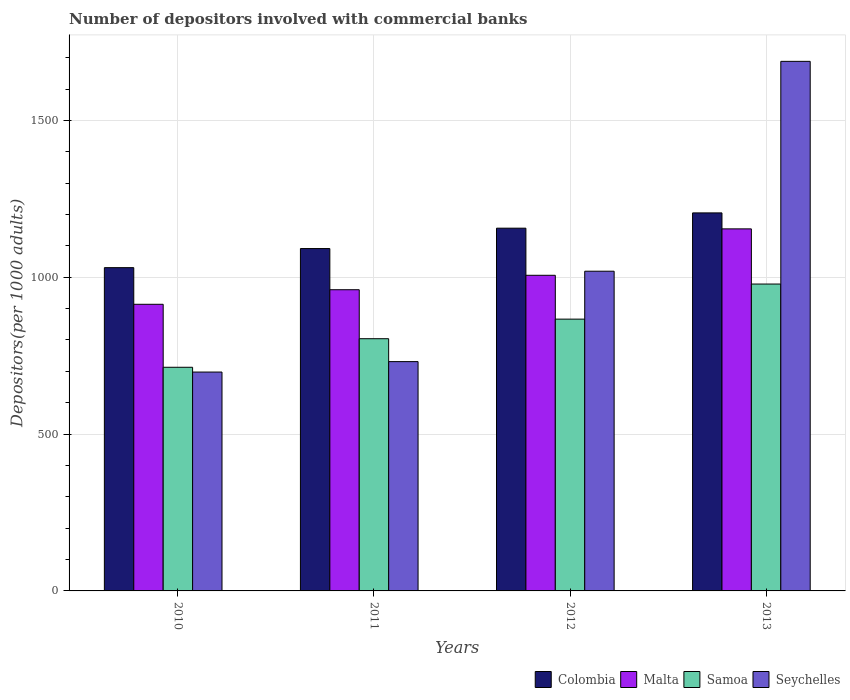How many groups of bars are there?
Give a very brief answer. 4. Are the number of bars per tick equal to the number of legend labels?
Offer a very short reply. Yes. Are the number of bars on each tick of the X-axis equal?
Give a very brief answer. Yes. What is the label of the 3rd group of bars from the left?
Your response must be concise. 2012. What is the number of depositors involved with commercial banks in Samoa in 2012?
Provide a succinct answer. 866.45. Across all years, what is the maximum number of depositors involved with commercial banks in Seychelles?
Make the answer very short. 1688.27. Across all years, what is the minimum number of depositors involved with commercial banks in Samoa?
Your answer should be compact. 713.02. In which year was the number of depositors involved with commercial banks in Seychelles maximum?
Provide a short and direct response. 2013. In which year was the number of depositors involved with commercial banks in Colombia minimum?
Your answer should be compact. 2010. What is the total number of depositors involved with commercial banks in Samoa in the graph?
Offer a terse response. 3361.86. What is the difference between the number of depositors involved with commercial banks in Colombia in 2010 and that in 2011?
Provide a succinct answer. -60.9. What is the difference between the number of depositors involved with commercial banks in Seychelles in 2010 and the number of depositors involved with commercial banks in Malta in 2012?
Give a very brief answer. -308.49. What is the average number of depositors involved with commercial banks in Samoa per year?
Offer a terse response. 840.47. In the year 2013, what is the difference between the number of depositors involved with commercial banks in Samoa and number of depositors involved with commercial banks in Colombia?
Give a very brief answer. -226.78. In how many years, is the number of depositors involved with commercial banks in Malta greater than 200?
Give a very brief answer. 4. What is the ratio of the number of depositors involved with commercial banks in Colombia in 2011 to that in 2013?
Give a very brief answer. 0.91. Is the number of depositors involved with commercial banks in Samoa in 2011 less than that in 2012?
Provide a succinct answer. Yes. What is the difference between the highest and the second highest number of depositors involved with commercial banks in Seychelles?
Your response must be concise. 669.03. What is the difference between the highest and the lowest number of depositors involved with commercial banks in Colombia?
Provide a succinct answer. 174.54. Is the sum of the number of depositors involved with commercial banks in Samoa in 2011 and 2012 greater than the maximum number of depositors involved with commercial banks in Malta across all years?
Offer a terse response. Yes. Is it the case that in every year, the sum of the number of depositors involved with commercial banks in Seychelles and number of depositors involved with commercial banks in Malta is greater than the sum of number of depositors involved with commercial banks in Samoa and number of depositors involved with commercial banks in Colombia?
Offer a very short reply. No. Is it the case that in every year, the sum of the number of depositors involved with commercial banks in Samoa and number of depositors involved with commercial banks in Seychelles is greater than the number of depositors involved with commercial banks in Malta?
Provide a succinct answer. Yes. How many years are there in the graph?
Give a very brief answer. 4. Are the values on the major ticks of Y-axis written in scientific E-notation?
Offer a very short reply. No. Does the graph contain any zero values?
Give a very brief answer. No. Does the graph contain grids?
Ensure brevity in your answer.  Yes. How many legend labels are there?
Your answer should be compact. 4. What is the title of the graph?
Give a very brief answer. Number of depositors involved with commercial banks. Does "Netherlands" appear as one of the legend labels in the graph?
Offer a very short reply. No. What is the label or title of the Y-axis?
Keep it short and to the point. Depositors(per 1000 adults). What is the Depositors(per 1000 adults) in Colombia in 2010?
Keep it short and to the point. 1030.59. What is the Depositors(per 1000 adults) of Malta in 2010?
Give a very brief answer. 913.8. What is the Depositors(per 1000 adults) of Samoa in 2010?
Make the answer very short. 713.02. What is the Depositors(per 1000 adults) of Seychelles in 2010?
Offer a terse response. 697.73. What is the Depositors(per 1000 adults) of Colombia in 2011?
Give a very brief answer. 1091.5. What is the Depositors(per 1000 adults) of Malta in 2011?
Provide a succinct answer. 960.23. What is the Depositors(per 1000 adults) of Samoa in 2011?
Keep it short and to the point. 804.04. What is the Depositors(per 1000 adults) in Seychelles in 2011?
Offer a terse response. 731.04. What is the Depositors(per 1000 adults) in Colombia in 2012?
Ensure brevity in your answer.  1156.43. What is the Depositors(per 1000 adults) in Malta in 2012?
Offer a very short reply. 1006.22. What is the Depositors(per 1000 adults) of Samoa in 2012?
Your answer should be very brief. 866.45. What is the Depositors(per 1000 adults) of Seychelles in 2012?
Keep it short and to the point. 1019.25. What is the Depositors(per 1000 adults) of Colombia in 2013?
Offer a terse response. 1205.13. What is the Depositors(per 1000 adults) of Malta in 2013?
Give a very brief answer. 1154.22. What is the Depositors(per 1000 adults) of Samoa in 2013?
Keep it short and to the point. 978.35. What is the Depositors(per 1000 adults) in Seychelles in 2013?
Your answer should be compact. 1688.27. Across all years, what is the maximum Depositors(per 1000 adults) in Colombia?
Make the answer very short. 1205.13. Across all years, what is the maximum Depositors(per 1000 adults) in Malta?
Ensure brevity in your answer.  1154.22. Across all years, what is the maximum Depositors(per 1000 adults) in Samoa?
Offer a very short reply. 978.35. Across all years, what is the maximum Depositors(per 1000 adults) in Seychelles?
Offer a terse response. 1688.27. Across all years, what is the minimum Depositors(per 1000 adults) of Colombia?
Make the answer very short. 1030.59. Across all years, what is the minimum Depositors(per 1000 adults) in Malta?
Ensure brevity in your answer.  913.8. Across all years, what is the minimum Depositors(per 1000 adults) in Samoa?
Offer a very short reply. 713.02. Across all years, what is the minimum Depositors(per 1000 adults) in Seychelles?
Provide a succinct answer. 697.73. What is the total Depositors(per 1000 adults) in Colombia in the graph?
Provide a succinct answer. 4483.65. What is the total Depositors(per 1000 adults) in Malta in the graph?
Make the answer very short. 4034.47. What is the total Depositors(per 1000 adults) in Samoa in the graph?
Your response must be concise. 3361.86. What is the total Depositors(per 1000 adults) of Seychelles in the graph?
Give a very brief answer. 4136.29. What is the difference between the Depositors(per 1000 adults) of Colombia in 2010 and that in 2011?
Provide a succinct answer. -60.9. What is the difference between the Depositors(per 1000 adults) in Malta in 2010 and that in 2011?
Provide a succinct answer. -46.43. What is the difference between the Depositors(per 1000 adults) in Samoa in 2010 and that in 2011?
Offer a terse response. -91.03. What is the difference between the Depositors(per 1000 adults) in Seychelles in 2010 and that in 2011?
Make the answer very short. -33.31. What is the difference between the Depositors(per 1000 adults) in Colombia in 2010 and that in 2012?
Provide a short and direct response. -125.84. What is the difference between the Depositors(per 1000 adults) in Malta in 2010 and that in 2012?
Provide a succinct answer. -92.42. What is the difference between the Depositors(per 1000 adults) of Samoa in 2010 and that in 2012?
Your response must be concise. -153.43. What is the difference between the Depositors(per 1000 adults) in Seychelles in 2010 and that in 2012?
Provide a succinct answer. -321.52. What is the difference between the Depositors(per 1000 adults) of Colombia in 2010 and that in 2013?
Offer a terse response. -174.54. What is the difference between the Depositors(per 1000 adults) in Malta in 2010 and that in 2013?
Provide a short and direct response. -240.42. What is the difference between the Depositors(per 1000 adults) of Samoa in 2010 and that in 2013?
Your answer should be compact. -265.33. What is the difference between the Depositors(per 1000 adults) of Seychelles in 2010 and that in 2013?
Make the answer very short. -990.54. What is the difference between the Depositors(per 1000 adults) in Colombia in 2011 and that in 2012?
Your answer should be very brief. -64.94. What is the difference between the Depositors(per 1000 adults) of Malta in 2011 and that in 2012?
Give a very brief answer. -45.99. What is the difference between the Depositors(per 1000 adults) of Samoa in 2011 and that in 2012?
Your answer should be compact. -62.41. What is the difference between the Depositors(per 1000 adults) in Seychelles in 2011 and that in 2012?
Provide a succinct answer. -288.21. What is the difference between the Depositors(per 1000 adults) of Colombia in 2011 and that in 2013?
Offer a very short reply. -113.64. What is the difference between the Depositors(per 1000 adults) in Malta in 2011 and that in 2013?
Provide a succinct answer. -193.99. What is the difference between the Depositors(per 1000 adults) in Samoa in 2011 and that in 2013?
Your answer should be very brief. -174.3. What is the difference between the Depositors(per 1000 adults) of Seychelles in 2011 and that in 2013?
Your response must be concise. -957.24. What is the difference between the Depositors(per 1000 adults) in Colombia in 2012 and that in 2013?
Give a very brief answer. -48.7. What is the difference between the Depositors(per 1000 adults) in Malta in 2012 and that in 2013?
Make the answer very short. -148. What is the difference between the Depositors(per 1000 adults) of Samoa in 2012 and that in 2013?
Offer a terse response. -111.9. What is the difference between the Depositors(per 1000 adults) of Seychelles in 2012 and that in 2013?
Offer a very short reply. -669.03. What is the difference between the Depositors(per 1000 adults) in Colombia in 2010 and the Depositors(per 1000 adults) in Malta in 2011?
Give a very brief answer. 70.36. What is the difference between the Depositors(per 1000 adults) of Colombia in 2010 and the Depositors(per 1000 adults) of Samoa in 2011?
Offer a terse response. 226.55. What is the difference between the Depositors(per 1000 adults) in Colombia in 2010 and the Depositors(per 1000 adults) in Seychelles in 2011?
Provide a succinct answer. 299.55. What is the difference between the Depositors(per 1000 adults) of Malta in 2010 and the Depositors(per 1000 adults) of Samoa in 2011?
Keep it short and to the point. 109.76. What is the difference between the Depositors(per 1000 adults) in Malta in 2010 and the Depositors(per 1000 adults) in Seychelles in 2011?
Offer a very short reply. 182.76. What is the difference between the Depositors(per 1000 adults) of Samoa in 2010 and the Depositors(per 1000 adults) of Seychelles in 2011?
Your answer should be compact. -18.02. What is the difference between the Depositors(per 1000 adults) in Colombia in 2010 and the Depositors(per 1000 adults) in Malta in 2012?
Provide a short and direct response. 24.37. What is the difference between the Depositors(per 1000 adults) of Colombia in 2010 and the Depositors(per 1000 adults) of Samoa in 2012?
Offer a terse response. 164.14. What is the difference between the Depositors(per 1000 adults) of Colombia in 2010 and the Depositors(per 1000 adults) of Seychelles in 2012?
Provide a short and direct response. 11.34. What is the difference between the Depositors(per 1000 adults) of Malta in 2010 and the Depositors(per 1000 adults) of Samoa in 2012?
Give a very brief answer. 47.35. What is the difference between the Depositors(per 1000 adults) in Malta in 2010 and the Depositors(per 1000 adults) in Seychelles in 2012?
Provide a succinct answer. -105.45. What is the difference between the Depositors(per 1000 adults) of Samoa in 2010 and the Depositors(per 1000 adults) of Seychelles in 2012?
Give a very brief answer. -306.23. What is the difference between the Depositors(per 1000 adults) in Colombia in 2010 and the Depositors(per 1000 adults) in Malta in 2013?
Your answer should be very brief. -123.63. What is the difference between the Depositors(per 1000 adults) in Colombia in 2010 and the Depositors(per 1000 adults) in Samoa in 2013?
Your answer should be compact. 52.24. What is the difference between the Depositors(per 1000 adults) of Colombia in 2010 and the Depositors(per 1000 adults) of Seychelles in 2013?
Your answer should be compact. -657.68. What is the difference between the Depositors(per 1000 adults) of Malta in 2010 and the Depositors(per 1000 adults) of Samoa in 2013?
Offer a terse response. -64.55. What is the difference between the Depositors(per 1000 adults) of Malta in 2010 and the Depositors(per 1000 adults) of Seychelles in 2013?
Ensure brevity in your answer.  -774.47. What is the difference between the Depositors(per 1000 adults) in Samoa in 2010 and the Depositors(per 1000 adults) in Seychelles in 2013?
Keep it short and to the point. -975.26. What is the difference between the Depositors(per 1000 adults) of Colombia in 2011 and the Depositors(per 1000 adults) of Malta in 2012?
Offer a very short reply. 85.28. What is the difference between the Depositors(per 1000 adults) of Colombia in 2011 and the Depositors(per 1000 adults) of Samoa in 2012?
Ensure brevity in your answer.  225.04. What is the difference between the Depositors(per 1000 adults) of Colombia in 2011 and the Depositors(per 1000 adults) of Seychelles in 2012?
Provide a short and direct response. 72.25. What is the difference between the Depositors(per 1000 adults) of Malta in 2011 and the Depositors(per 1000 adults) of Samoa in 2012?
Keep it short and to the point. 93.78. What is the difference between the Depositors(per 1000 adults) of Malta in 2011 and the Depositors(per 1000 adults) of Seychelles in 2012?
Offer a terse response. -59.02. What is the difference between the Depositors(per 1000 adults) in Samoa in 2011 and the Depositors(per 1000 adults) in Seychelles in 2012?
Your answer should be very brief. -215.2. What is the difference between the Depositors(per 1000 adults) in Colombia in 2011 and the Depositors(per 1000 adults) in Malta in 2013?
Provide a succinct answer. -62.72. What is the difference between the Depositors(per 1000 adults) in Colombia in 2011 and the Depositors(per 1000 adults) in Samoa in 2013?
Keep it short and to the point. 113.15. What is the difference between the Depositors(per 1000 adults) of Colombia in 2011 and the Depositors(per 1000 adults) of Seychelles in 2013?
Provide a succinct answer. -596.78. What is the difference between the Depositors(per 1000 adults) in Malta in 2011 and the Depositors(per 1000 adults) in Samoa in 2013?
Give a very brief answer. -18.12. What is the difference between the Depositors(per 1000 adults) of Malta in 2011 and the Depositors(per 1000 adults) of Seychelles in 2013?
Keep it short and to the point. -728.04. What is the difference between the Depositors(per 1000 adults) of Samoa in 2011 and the Depositors(per 1000 adults) of Seychelles in 2013?
Offer a terse response. -884.23. What is the difference between the Depositors(per 1000 adults) of Colombia in 2012 and the Depositors(per 1000 adults) of Malta in 2013?
Offer a very short reply. 2.21. What is the difference between the Depositors(per 1000 adults) of Colombia in 2012 and the Depositors(per 1000 adults) of Samoa in 2013?
Make the answer very short. 178.08. What is the difference between the Depositors(per 1000 adults) in Colombia in 2012 and the Depositors(per 1000 adults) in Seychelles in 2013?
Ensure brevity in your answer.  -531.84. What is the difference between the Depositors(per 1000 adults) of Malta in 2012 and the Depositors(per 1000 adults) of Samoa in 2013?
Your answer should be compact. 27.87. What is the difference between the Depositors(per 1000 adults) of Malta in 2012 and the Depositors(per 1000 adults) of Seychelles in 2013?
Keep it short and to the point. -682.05. What is the difference between the Depositors(per 1000 adults) of Samoa in 2012 and the Depositors(per 1000 adults) of Seychelles in 2013?
Provide a succinct answer. -821.82. What is the average Depositors(per 1000 adults) of Colombia per year?
Your answer should be compact. 1120.91. What is the average Depositors(per 1000 adults) in Malta per year?
Keep it short and to the point. 1008.62. What is the average Depositors(per 1000 adults) in Samoa per year?
Your answer should be compact. 840.47. What is the average Depositors(per 1000 adults) of Seychelles per year?
Offer a very short reply. 1034.07. In the year 2010, what is the difference between the Depositors(per 1000 adults) in Colombia and Depositors(per 1000 adults) in Malta?
Your answer should be compact. 116.79. In the year 2010, what is the difference between the Depositors(per 1000 adults) of Colombia and Depositors(per 1000 adults) of Samoa?
Your answer should be compact. 317.57. In the year 2010, what is the difference between the Depositors(per 1000 adults) in Colombia and Depositors(per 1000 adults) in Seychelles?
Make the answer very short. 332.86. In the year 2010, what is the difference between the Depositors(per 1000 adults) of Malta and Depositors(per 1000 adults) of Samoa?
Keep it short and to the point. 200.78. In the year 2010, what is the difference between the Depositors(per 1000 adults) of Malta and Depositors(per 1000 adults) of Seychelles?
Provide a succinct answer. 216.07. In the year 2010, what is the difference between the Depositors(per 1000 adults) of Samoa and Depositors(per 1000 adults) of Seychelles?
Your answer should be compact. 15.29. In the year 2011, what is the difference between the Depositors(per 1000 adults) in Colombia and Depositors(per 1000 adults) in Malta?
Your answer should be compact. 131.27. In the year 2011, what is the difference between the Depositors(per 1000 adults) of Colombia and Depositors(per 1000 adults) of Samoa?
Make the answer very short. 287.45. In the year 2011, what is the difference between the Depositors(per 1000 adults) of Colombia and Depositors(per 1000 adults) of Seychelles?
Offer a very short reply. 360.46. In the year 2011, what is the difference between the Depositors(per 1000 adults) in Malta and Depositors(per 1000 adults) in Samoa?
Your response must be concise. 156.19. In the year 2011, what is the difference between the Depositors(per 1000 adults) of Malta and Depositors(per 1000 adults) of Seychelles?
Provide a succinct answer. 229.19. In the year 2011, what is the difference between the Depositors(per 1000 adults) of Samoa and Depositors(per 1000 adults) of Seychelles?
Give a very brief answer. 73.01. In the year 2012, what is the difference between the Depositors(per 1000 adults) of Colombia and Depositors(per 1000 adults) of Malta?
Give a very brief answer. 150.21. In the year 2012, what is the difference between the Depositors(per 1000 adults) of Colombia and Depositors(per 1000 adults) of Samoa?
Provide a succinct answer. 289.98. In the year 2012, what is the difference between the Depositors(per 1000 adults) of Colombia and Depositors(per 1000 adults) of Seychelles?
Your answer should be very brief. 137.19. In the year 2012, what is the difference between the Depositors(per 1000 adults) in Malta and Depositors(per 1000 adults) in Samoa?
Keep it short and to the point. 139.77. In the year 2012, what is the difference between the Depositors(per 1000 adults) of Malta and Depositors(per 1000 adults) of Seychelles?
Make the answer very short. -13.03. In the year 2012, what is the difference between the Depositors(per 1000 adults) in Samoa and Depositors(per 1000 adults) in Seychelles?
Ensure brevity in your answer.  -152.79. In the year 2013, what is the difference between the Depositors(per 1000 adults) in Colombia and Depositors(per 1000 adults) in Malta?
Your response must be concise. 50.92. In the year 2013, what is the difference between the Depositors(per 1000 adults) in Colombia and Depositors(per 1000 adults) in Samoa?
Keep it short and to the point. 226.78. In the year 2013, what is the difference between the Depositors(per 1000 adults) in Colombia and Depositors(per 1000 adults) in Seychelles?
Your answer should be compact. -483.14. In the year 2013, what is the difference between the Depositors(per 1000 adults) in Malta and Depositors(per 1000 adults) in Samoa?
Offer a terse response. 175.87. In the year 2013, what is the difference between the Depositors(per 1000 adults) in Malta and Depositors(per 1000 adults) in Seychelles?
Keep it short and to the point. -534.06. In the year 2013, what is the difference between the Depositors(per 1000 adults) in Samoa and Depositors(per 1000 adults) in Seychelles?
Keep it short and to the point. -709.92. What is the ratio of the Depositors(per 1000 adults) in Colombia in 2010 to that in 2011?
Make the answer very short. 0.94. What is the ratio of the Depositors(per 1000 adults) in Malta in 2010 to that in 2011?
Provide a short and direct response. 0.95. What is the ratio of the Depositors(per 1000 adults) of Samoa in 2010 to that in 2011?
Your answer should be compact. 0.89. What is the ratio of the Depositors(per 1000 adults) in Seychelles in 2010 to that in 2011?
Offer a terse response. 0.95. What is the ratio of the Depositors(per 1000 adults) in Colombia in 2010 to that in 2012?
Your answer should be very brief. 0.89. What is the ratio of the Depositors(per 1000 adults) in Malta in 2010 to that in 2012?
Offer a very short reply. 0.91. What is the ratio of the Depositors(per 1000 adults) of Samoa in 2010 to that in 2012?
Give a very brief answer. 0.82. What is the ratio of the Depositors(per 1000 adults) in Seychelles in 2010 to that in 2012?
Ensure brevity in your answer.  0.68. What is the ratio of the Depositors(per 1000 adults) of Colombia in 2010 to that in 2013?
Ensure brevity in your answer.  0.86. What is the ratio of the Depositors(per 1000 adults) in Malta in 2010 to that in 2013?
Your answer should be very brief. 0.79. What is the ratio of the Depositors(per 1000 adults) in Samoa in 2010 to that in 2013?
Your answer should be very brief. 0.73. What is the ratio of the Depositors(per 1000 adults) of Seychelles in 2010 to that in 2013?
Offer a very short reply. 0.41. What is the ratio of the Depositors(per 1000 adults) in Colombia in 2011 to that in 2012?
Offer a very short reply. 0.94. What is the ratio of the Depositors(per 1000 adults) of Malta in 2011 to that in 2012?
Ensure brevity in your answer.  0.95. What is the ratio of the Depositors(per 1000 adults) in Samoa in 2011 to that in 2012?
Keep it short and to the point. 0.93. What is the ratio of the Depositors(per 1000 adults) of Seychelles in 2011 to that in 2012?
Give a very brief answer. 0.72. What is the ratio of the Depositors(per 1000 adults) in Colombia in 2011 to that in 2013?
Your response must be concise. 0.91. What is the ratio of the Depositors(per 1000 adults) in Malta in 2011 to that in 2013?
Provide a short and direct response. 0.83. What is the ratio of the Depositors(per 1000 adults) in Samoa in 2011 to that in 2013?
Give a very brief answer. 0.82. What is the ratio of the Depositors(per 1000 adults) of Seychelles in 2011 to that in 2013?
Ensure brevity in your answer.  0.43. What is the ratio of the Depositors(per 1000 adults) in Colombia in 2012 to that in 2013?
Your answer should be very brief. 0.96. What is the ratio of the Depositors(per 1000 adults) in Malta in 2012 to that in 2013?
Provide a succinct answer. 0.87. What is the ratio of the Depositors(per 1000 adults) in Samoa in 2012 to that in 2013?
Make the answer very short. 0.89. What is the ratio of the Depositors(per 1000 adults) in Seychelles in 2012 to that in 2013?
Your answer should be compact. 0.6. What is the difference between the highest and the second highest Depositors(per 1000 adults) in Colombia?
Make the answer very short. 48.7. What is the difference between the highest and the second highest Depositors(per 1000 adults) of Malta?
Provide a short and direct response. 148. What is the difference between the highest and the second highest Depositors(per 1000 adults) in Samoa?
Provide a short and direct response. 111.9. What is the difference between the highest and the second highest Depositors(per 1000 adults) in Seychelles?
Your answer should be very brief. 669.03. What is the difference between the highest and the lowest Depositors(per 1000 adults) of Colombia?
Your answer should be compact. 174.54. What is the difference between the highest and the lowest Depositors(per 1000 adults) in Malta?
Offer a very short reply. 240.42. What is the difference between the highest and the lowest Depositors(per 1000 adults) of Samoa?
Your response must be concise. 265.33. What is the difference between the highest and the lowest Depositors(per 1000 adults) of Seychelles?
Offer a terse response. 990.54. 